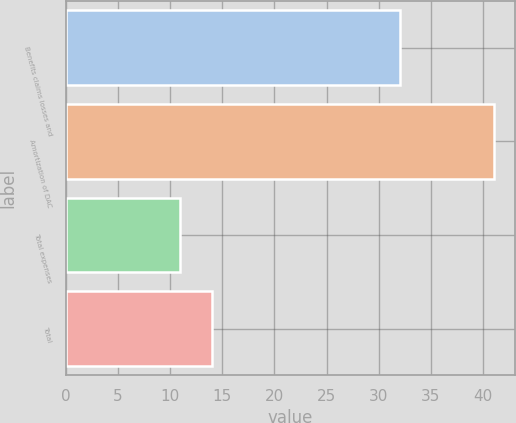<chart> <loc_0><loc_0><loc_500><loc_500><bar_chart><fcel>Benefits claims losses and<fcel>Amortization of DAC<fcel>Total expenses<fcel>Total<nl><fcel>32<fcel>41<fcel>11<fcel>14<nl></chart> 